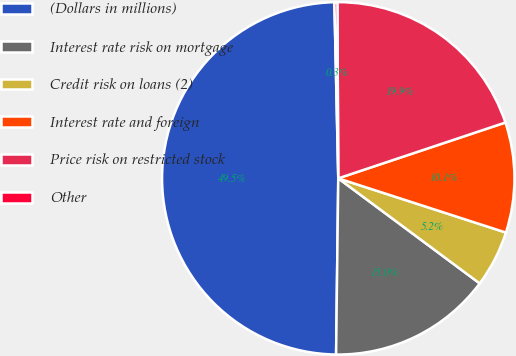<chart> <loc_0><loc_0><loc_500><loc_500><pie_chart><fcel>(Dollars in millions)<fcel>Interest rate risk on mortgage<fcel>Credit risk on loans (2)<fcel>Interest rate and foreign<fcel>Price risk on restricted stock<fcel>Other<nl><fcel>49.46%<fcel>15.03%<fcel>5.19%<fcel>10.11%<fcel>19.95%<fcel>0.27%<nl></chart> 